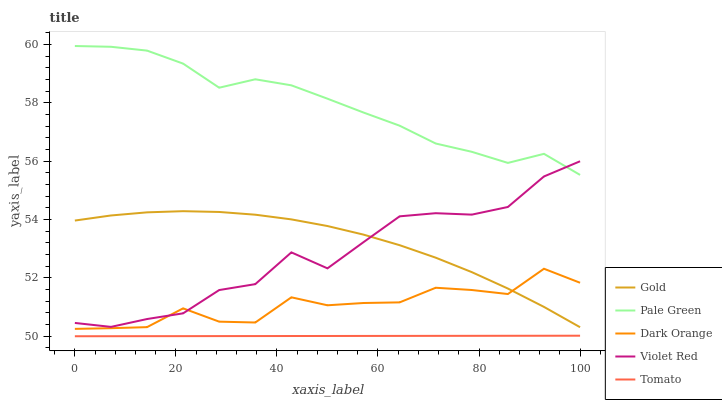Does Tomato have the minimum area under the curve?
Answer yes or no. Yes. Does Pale Green have the maximum area under the curve?
Answer yes or no. Yes. Does Dark Orange have the minimum area under the curve?
Answer yes or no. No. Does Dark Orange have the maximum area under the curve?
Answer yes or no. No. Is Tomato the smoothest?
Answer yes or no. Yes. Is Violet Red the roughest?
Answer yes or no. Yes. Is Dark Orange the smoothest?
Answer yes or no. No. Is Dark Orange the roughest?
Answer yes or no. No. Does Tomato have the lowest value?
Answer yes or no. Yes. Does Dark Orange have the lowest value?
Answer yes or no. No. Does Pale Green have the highest value?
Answer yes or no. Yes. Does Dark Orange have the highest value?
Answer yes or no. No. Is Tomato less than Pale Green?
Answer yes or no. Yes. Is Dark Orange greater than Tomato?
Answer yes or no. Yes. Does Gold intersect Dark Orange?
Answer yes or no. Yes. Is Gold less than Dark Orange?
Answer yes or no. No. Is Gold greater than Dark Orange?
Answer yes or no. No. Does Tomato intersect Pale Green?
Answer yes or no. No. 